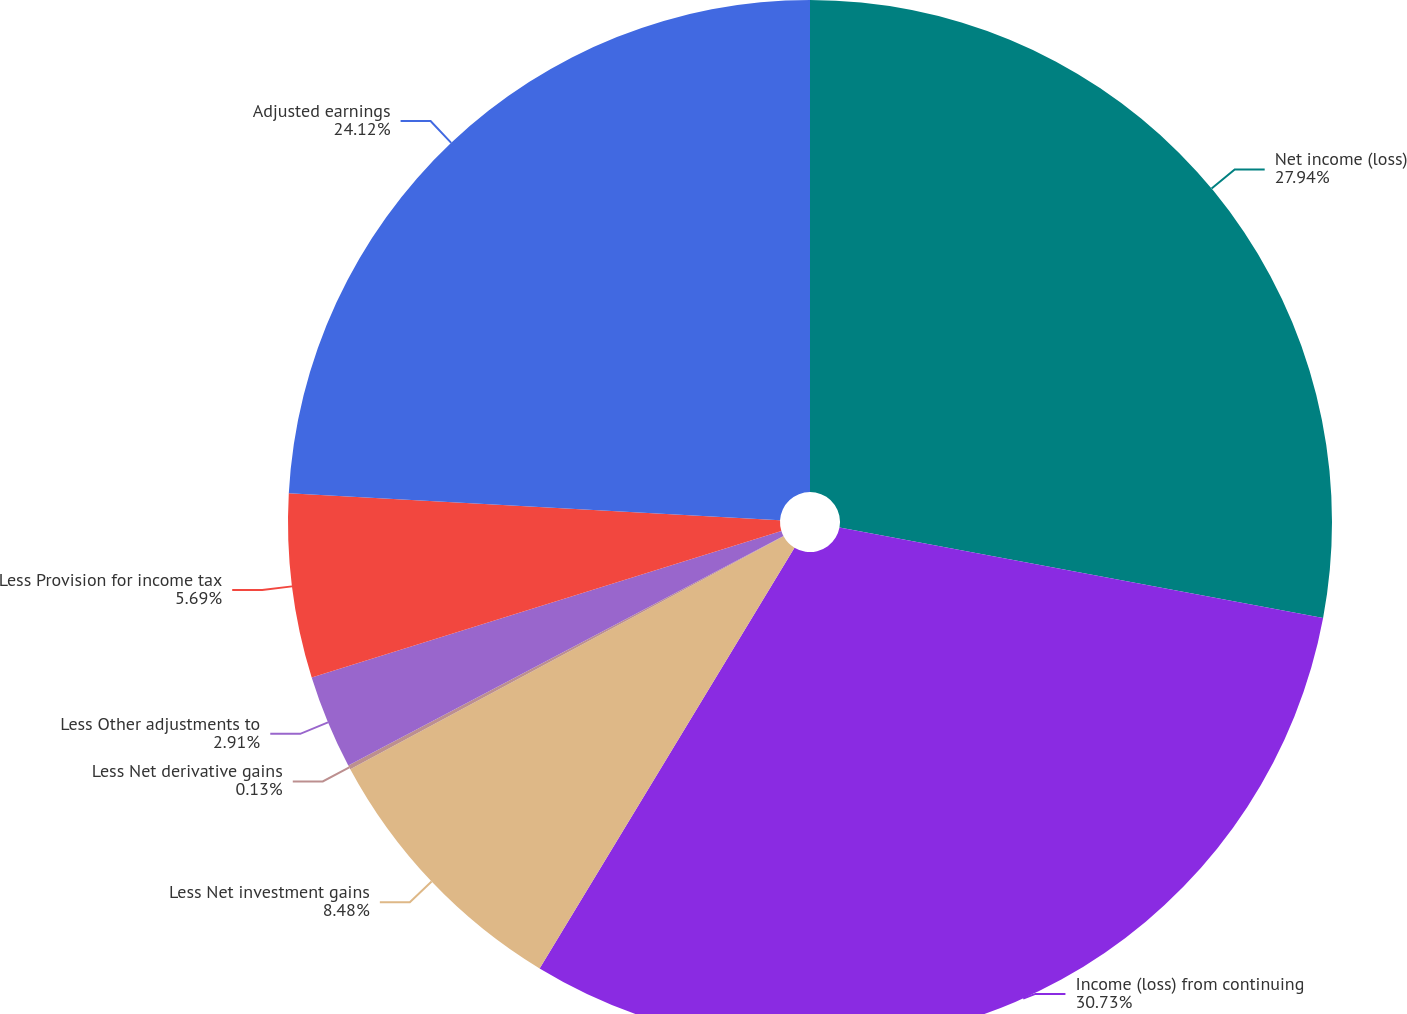<chart> <loc_0><loc_0><loc_500><loc_500><pie_chart><fcel>Net income (loss)<fcel>Income (loss) from continuing<fcel>Less Net investment gains<fcel>Less Net derivative gains<fcel>Less Other adjustments to<fcel>Less Provision for income tax<fcel>Adjusted earnings<nl><fcel>27.94%<fcel>30.72%<fcel>8.48%<fcel>0.13%<fcel>2.91%<fcel>5.69%<fcel>24.12%<nl></chart> 